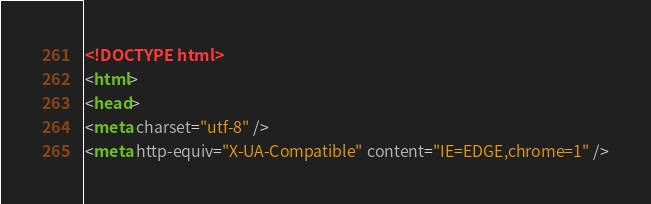<code> <loc_0><loc_0><loc_500><loc_500><_HTML_><!DOCTYPE html>
<html>
<head>
<meta charset="utf-8" />
<meta http-equiv="X-UA-Compatible" content="IE=EDGE,chrome=1" /></code> 